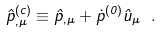Convert formula to latex. <formula><loc_0><loc_0><loc_500><loc_500>\hat { p } ^ { \left ( c \right ) } _ { , \mu } \equiv \hat { p } _ { , \mu } + \dot { p } ^ { \left ( 0 \right ) } \hat { u } _ { \mu } \ .</formula> 